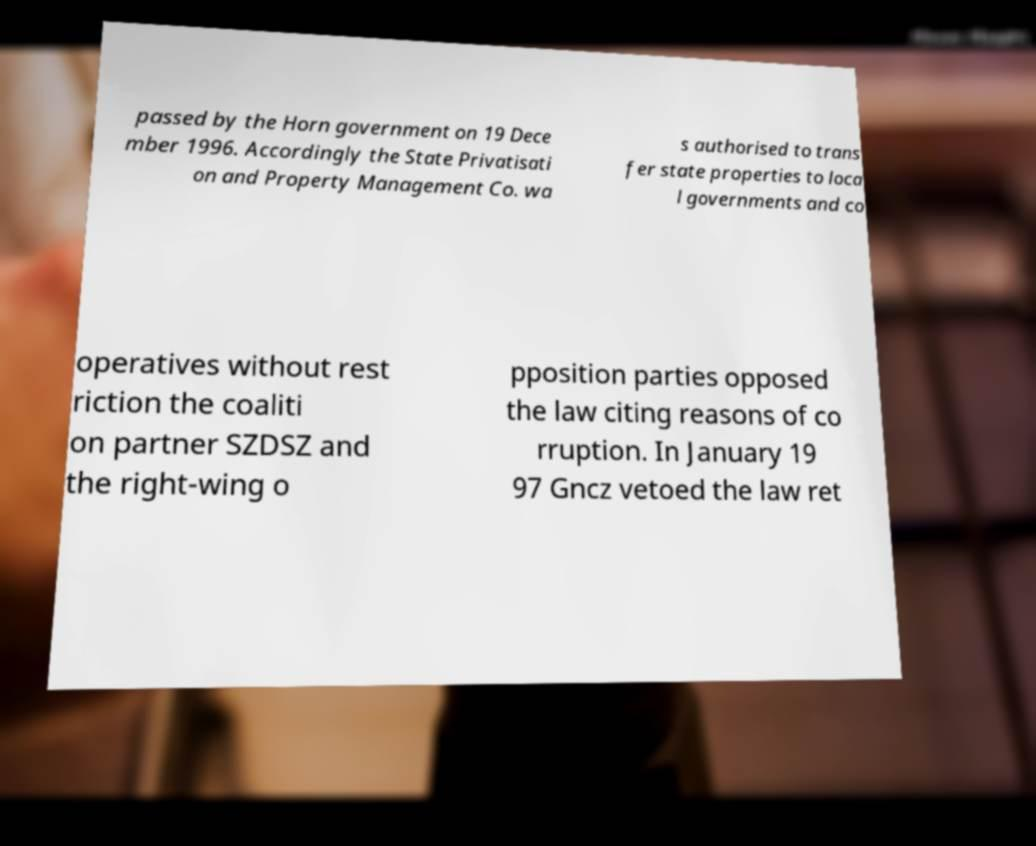For documentation purposes, I need the text within this image transcribed. Could you provide that? passed by the Horn government on 19 Dece mber 1996. Accordingly the State Privatisati on and Property Management Co. wa s authorised to trans fer state properties to loca l governments and co operatives without rest riction the coaliti on partner SZDSZ and the right-wing o pposition parties opposed the law citing reasons of co rruption. In January 19 97 Gncz vetoed the law ret 